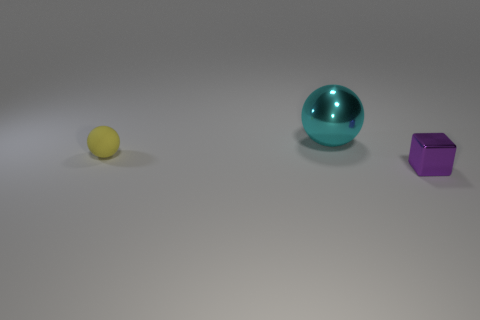Add 3 big cylinders. How many objects exist? 6 Subtract all spheres. How many objects are left? 1 Add 3 purple metal blocks. How many purple metal blocks are left? 4 Add 1 metallic spheres. How many metallic spheres exist? 2 Subtract 0 green blocks. How many objects are left? 3 Subtract all purple metallic objects. Subtract all tiny yellow objects. How many objects are left? 1 